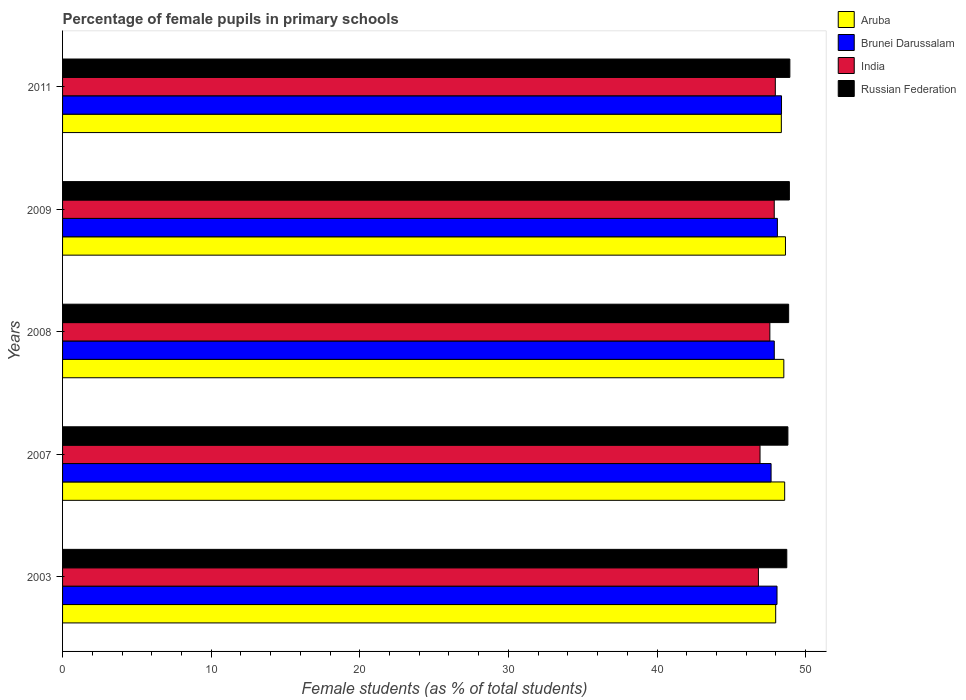Are the number of bars per tick equal to the number of legend labels?
Offer a terse response. Yes. Are the number of bars on each tick of the Y-axis equal?
Offer a terse response. Yes. How many bars are there on the 4th tick from the top?
Provide a short and direct response. 4. What is the label of the 4th group of bars from the top?
Ensure brevity in your answer.  2007. What is the percentage of female pupils in primary schools in India in 2009?
Offer a terse response. 47.89. Across all years, what is the maximum percentage of female pupils in primary schools in Russian Federation?
Offer a terse response. 48.94. Across all years, what is the minimum percentage of female pupils in primary schools in Aruba?
Your answer should be compact. 47.98. What is the total percentage of female pupils in primary schools in Aruba in the graph?
Provide a short and direct response. 242.11. What is the difference between the percentage of female pupils in primary schools in India in 2007 and that in 2009?
Give a very brief answer. -0.96. What is the difference between the percentage of female pupils in primary schools in India in 2007 and the percentage of female pupils in primary schools in Brunei Darussalam in 2003?
Your response must be concise. -1.14. What is the average percentage of female pupils in primary schools in Aruba per year?
Keep it short and to the point. 48.42. In the year 2009, what is the difference between the percentage of female pupils in primary schools in India and percentage of female pupils in primary schools in Brunei Darussalam?
Give a very brief answer. -0.21. What is the ratio of the percentage of female pupils in primary schools in Aruba in 2008 to that in 2011?
Your answer should be very brief. 1. Is the percentage of female pupils in primary schools in Russian Federation in 2007 less than that in 2011?
Give a very brief answer. Yes. Is the difference between the percentage of female pupils in primary schools in India in 2009 and 2011 greater than the difference between the percentage of female pupils in primary schools in Brunei Darussalam in 2009 and 2011?
Provide a succinct answer. Yes. What is the difference between the highest and the second highest percentage of female pupils in primary schools in Brunei Darussalam?
Ensure brevity in your answer.  0.28. What is the difference between the highest and the lowest percentage of female pupils in primary schools in Russian Federation?
Make the answer very short. 0.21. In how many years, is the percentage of female pupils in primary schools in Brunei Darussalam greater than the average percentage of female pupils in primary schools in Brunei Darussalam taken over all years?
Provide a succinct answer. 3. Is the sum of the percentage of female pupils in primary schools in Aruba in 2003 and 2009 greater than the maximum percentage of female pupils in primary schools in Brunei Darussalam across all years?
Make the answer very short. Yes. What does the 1st bar from the top in 2007 represents?
Provide a succinct answer. Russian Federation. What does the 1st bar from the bottom in 2007 represents?
Offer a very short reply. Aruba. Are all the bars in the graph horizontal?
Make the answer very short. Yes. Does the graph contain grids?
Make the answer very short. No. What is the title of the graph?
Your response must be concise. Percentage of female pupils in primary schools. What is the label or title of the X-axis?
Offer a terse response. Female students (as % of total students). What is the label or title of the Y-axis?
Keep it short and to the point. Years. What is the Female students (as % of total students) of Aruba in 2003?
Ensure brevity in your answer.  47.98. What is the Female students (as % of total students) in Brunei Darussalam in 2003?
Ensure brevity in your answer.  48.07. What is the Female students (as % of total students) of India in 2003?
Provide a short and direct response. 46.82. What is the Female students (as % of total students) of Russian Federation in 2003?
Your answer should be very brief. 48.73. What is the Female students (as % of total students) of Aruba in 2007?
Provide a short and direct response. 48.59. What is the Female students (as % of total students) in Brunei Darussalam in 2007?
Your response must be concise. 47.67. What is the Female students (as % of total students) in India in 2007?
Provide a succinct answer. 46.93. What is the Female students (as % of total students) of Russian Federation in 2007?
Ensure brevity in your answer.  48.81. What is the Female students (as % of total students) of Aruba in 2008?
Your answer should be very brief. 48.53. What is the Female students (as % of total students) of Brunei Darussalam in 2008?
Give a very brief answer. 47.89. What is the Female students (as % of total students) in India in 2008?
Give a very brief answer. 47.59. What is the Female students (as % of total students) in Russian Federation in 2008?
Your answer should be compact. 48.86. What is the Female students (as % of total students) of Aruba in 2009?
Give a very brief answer. 48.64. What is the Female students (as % of total students) in Brunei Darussalam in 2009?
Your answer should be compact. 48.1. What is the Female students (as % of total students) in India in 2009?
Offer a terse response. 47.89. What is the Female students (as % of total students) in Russian Federation in 2009?
Ensure brevity in your answer.  48.9. What is the Female students (as % of total students) of Aruba in 2011?
Offer a terse response. 48.36. What is the Female students (as % of total students) of Brunei Darussalam in 2011?
Your answer should be very brief. 48.38. What is the Female students (as % of total students) of India in 2011?
Provide a succinct answer. 47.96. What is the Female students (as % of total students) of Russian Federation in 2011?
Your answer should be very brief. 48.94. Across all years, what is the maximum Female students (as % of total students) of Aruba?
Make the answer very short. 48.64. Across all years, what is the maximum Female students (as % of total students) of Brunei Darussalam?
Make the answer very short. 48.38. Across all years, what is the maximum Female students (as % of total students) of India?
Keep it short and to the point. 47.96. Across all years, what is the maximum Female students (as % of total students) of Russian Federation?
Offer a very short reply. 48.94. Across all years, what is the minimum Female students (as % of total students) of Aruba?
Ensure brevity in your answer.  47.98. Across all years, what is the minimum Female students (as % of total students) in Brunei Darussalam?
Give a very brief answer. 47.67. Across all years, what is the minimum Female students (as % of total students) of India?
Make the answer very short. 46.82. Across all years, what is the minimum Female students (as % of total students) of Russian Federation?
Your answer should be compact. 48.73. What is the total Female students (as % of total students) in Aruba in the graph?
Give a very brief answer. 242.11. What is the total Female students (as % of total students) of Brunei Darussalam in the graph?
Your response must be concise. 240.11. What is the total Female students (as % of total students) in India in the graph?
Provide a succinct answer. 237.19. What is the total Female students (as % of total students) of Russian Federation in the graph?
Give a very brief answer. 244.24. What is the difference between the Female students (as % of total students) of Aruba in 2003 and that in 2007?
Provide a succinct answer. -0.6. What is the difference between the Female students (as % of total students) of Brunei Darussalam in 2003 and that in 2007?
Give a very brief answer. 0.4. What is the difference between the Female students (as % of total students) of India in 2003 and that in 2007?
Your answer should be very brief. -0.11. What is the difference between the Female students (as % of total students) in Russian Federation in 2003 and that in 2007?
Your answer should be compact. -0.07. What is the difference between the Female students (as % of total students) of Aruba in 2003 and that in 2008?
Provide a short and direct response. -0.55. What is the difference between the Female students (as % of total students) in Brunei Darussalam in 2003 and that in 2008?
Offer a terse response. 0.18. What is the difference between the Female students (as % of total students) of India in 2003 and that in 2008?
Offer a very short reply. -0.77. What is the difference between the Female students (as % of total students) of Russian Federation in 2003 and that in 2008?
Ensure brevity in your answer.  -0.12. What is the difference between the Female students (as % of total students) in Aruba in 2003 and that in 2009?
Provide a short and direct response. -0.66. What is the difference between the Female students (as % of total students) in Brunei Darussalam in 2003 and that in 2009?
Offer a very short reply. -0.03. What is the difference between the Female students (as % of total students) of India in 2003 and that in 2009?
Give a very brief answer. -1.06. What is the difference between the Female students (as % of total students) of Russian Federation in 2003 and that in 2009?
Give a very brief answer. -0.17. What is the difference between the Female students (as % of total students) in Aruba in 2003 and that in 2011?
Make the answer very short. -0.38. What is the difference between the Female students (as % of total students) in Brunei Darussalam in 2003 and that in 2011?
Keep it short and to the point. -0.3. What is the difference between the Female students (as % of total students) of India in 2003 and that in 2011?
Give a very brief answer. -1.14. What is the difference between the Female students (as % of total students) of Russian Federation in 2003 and that in 2011?
Your answer should be compact. -0.21. What is the difference between the Female students (as % of total students) of Aruba in 2007 and that in 2008?
Keep it short and to the point. 0.06. What is the difference between the Female students (as % of total students) of Brunei Darussalam in 2007 and that in 2008?
Offer a terse response. -0.21. What is the difference between the Female students (as % of total students) in India in 2007 and that in 2008?
Make the answer very short. -0.66. What is the difference between the Female students (as % of total students) in Russian Federation in 2007 and that in 2008?
Keep it short and to the point. -0.05. What is the difference between the Female students (as % of total students) in Aruba in 2007 and that in 2009?
Your response must be concise. -0.05. What is the difference between the Female students (as % of total students) in Brunei Darussalam in 2007 and that in 2009?
Your response must be concise. -0.42. What is the difference between the Female students (as % of total students) in India in 2007 and that in 2009?
Your answer should be very brief. -0.96. What is the difference between the Female students (as % of total students) of Russian Federation in 2007 and that in 2009?
Your response must be concise. -0.1. What is the difference between the Female students (as % of total students) in Aruba in 2007 and that in 2011?
Give a very brief answer. 0.22. What is the difference between the Female students (as % of total students) of Brunei Darussalam in 2007 and that in 2011?
Keep it short and to the point. -0.7. What is the difference between the Female students (as % of total students) of India in 2007 and that in 2011?
Offer a terse response. -1.03. What is the difference between the Female students (as % of total students) of Russian Federation in 2007 and that in 2011?
Your answer should be very brief. -0.13. What is the difference between the Female students (as % of total students) of Aruba in 2008 and that in 2009?
Make the answer very short. -0.11. What is the difference between the Female students (as % of total students) of Brunei Darussalam in 2008 and that in 2009?
Provide a short and direct response. -0.21. What is the difference between the Female students (as % of total students) of India in 2008 and that in 2009?
Make the answer very short. -0.29. What is the difference between the Female students (as % of total students) in Russian Federation in 2008 and that in 2009?
Make the answer very short. -0.05. What is the difference between the Female students (as % of total students) of Aruba in 2008 and that in 2011?
Provide a succinct answer. 0.17. What is the difference between the Female students (as % of total students) in Brunei Darussalam in 2008 and that in 2011?
Your answer should be compact. -0.49. What is the difference between the Female students (as % of total students) of India in 2008 and that in 2011?
Your answer should be very brief. -0.37. What is the difference between the Female students (as % of total students) of Russian Federation in 2008 and that in 2011?
Provide a succinct answer. -0.08. What is the difference between the Female students (as % of total students) of Aruba in 2009 and that in 2011?
Offer a terse response. 0.28. What is the difference between the Female students (as % of total students) of Brunei Darussalam in 2009 and that in 2011?
Your answer should be compact. -0.28. What is the difference between the Female students (as % of total students) in India in 2009 and that in 2011?
Ensure brevity in your answer.  -0.07. What is the difference between the Female students (as % of total students) in Russian Federation in 2009 and that in 2011?
Provide a short and direct response. -0.03. What is the difference between the Female students (as % of total students) in Aruba in 2003 and the Female students (as % of total students) in Brunei Darussalam in 2007?
Your answer should be compact. 0.31. What is the difference between the Female students (as % of total students) in Aruba in 2003 and the Female students (as % of total students) in India in 2007?
Offer a terse response. 1.05. What is the difference between the Female students (as % of total students) of Aruba in 2003 and the Female students (as % of total students) of Russian Federation in 2007?
Offer a terse response. -0.82. What is the difference between the Female students (as % of total students) of Brunei Darussalam in 2003 and the Female students (as % of total students) of India in 2007?
Provide a succinct answer. 1.14. What is the difference between the Female students (as % of total students) of Brunei Darussalam in 2003 and the Female students (as % of total students) of Russian Federation in 2007?
Offer a terse response. -0.73. What is the difference between the Female students (as % of total students) in India in 2003 and the Female students (as % of total students) in Russian Federation in 2007?
Ensure brevity in your answer.  -1.98. What is the difference between the Female students (as % of total students) in Aruba in 2003 and the Female students (as % of total students) in Brunei Darussalam in 2008?
Keep it short and to the point. 0.1. What is the difference between the Female students (as % of total students) of Aruba in 2003 and the Female students (as % of total students) of India in 2008?
Offer a terse response. 0.39. What is the difference between the Female students (as % of total students) of Aruba in 2003 and the Female students (as % of total students) of Russian Federation in 2008?
Provide a short and direct response. -0.87. What is the difference between the Female students (as % of total students) of Brunei Darussalam in 2003 and the Female students (as % of total students) of India in 2008?
Make the answer very short. 0.48. What is the difference between the Female students (as % of total students) in Brunei Darussalam in 2003 and the Female students (as % of total students) in Russian Federation in 2008?
Keep it short and to the point. -0.78. What is the difference between the Female students (as % of total students) in India in 2003 and the Female students (as % of total students) in Russian Federation in 2008?
Your answer should be compact. -2.03. What is the difference between the Female students (as % of total students) in Aruba in 2003 and the Female students (as % of total students) in Brunei Darussalam in 2009?
Provide a short and direct response. -0.11. What is the difference between the Female students (as % of total students) in Aruba in 2003 and the Female students (as % of total students) in India in 2009?
Your response must be concise. 0.1. What is the difference between the Female students (as % of total students) in Aruba in 2003 and the Female students (as % of total students) in Russian Federation in 2009?
Your response must be concise. -0.92. What is the difference between the Female students (as % of total students) of Brunei Darussalam in 2003 and the Female students (as % of total students) of India in 2009?
Give a very brief answer. 0.19. What is the difference between the Female students (as % of total students) of Brunei Darussalam in 2003 and the Female students (as % of total students) of Russian Federation in 2009?
Provide a short and direct response. -0.83. What is the difference between the Female students (as % of total students) of India in 2003 and the Female students (as % of total students) of Russian Federation in 2009?
Keep it short and to the point. -2.08. What is the difference between the Female students (as % of total students) of Aruba in 2003 and the Female students (as % of total students) of Brunei Darussalam in 2011?
Your answer should be compact. -0.39. What is the difference between the Female students (as % of total students) of Aruba in 2003 and the Female students (as % of total students) of India in 2011?
Provide a short and direct response. 0.02. What is the difference between the Female students (as % of total students) of Aruba in 2003 and the Female students (as % of total students) of Russian Federation in 2011?
Provide a short and direct response. -0.95. What is the difference between the Female students (as % of total students) in Brunei Darussalam in 2003 and the Female students (as % of total students) in India in 2011?
Make the answer very short. 0.11. What is the difference between the Female students (as % of total students) of Brunei Darussalam in 2003 and the Female students (as % of total students) of Russian Federation in 2011?
Your response must be concise. -0.86. What is the difference between the Female students (as % of total students) of India in 2003 and the Female students (as % of total students) of Russian Federation in 2011?
Your answer should be very brief. -2.12. What is the difference between the Female students (as % of total students) in Aruba in 2007 and the Female students (as % of total students) in Brunei Darussalam in 2008?
Your answer should be compact. 0.7. What is the difference between the Female students (as % of total students) in Aruba in 2007 and the Female students (as % of total students) in India in 2008?
Provide a succinct answer. 1. What is the difference between the Female students (as % of total students) in Aruba in 2007 and the Female students (as % of total students) in Russian Federation in 2008?
Give a very brief answer. -0.27. What is the difference between the Female students (as % of total students) in Brunei Darussalam in 2007 and the Female students (as % of total students) in India in 2008?
Keep it short and to the point. 0.08. What is the difference between the Female students (as % of total students) of Brunei Darussalam in 2007 and the Female students (as % of total students) of Russian Federation in 2008?
Offer a very short reply. -1.18. What is the difference between the Female students (as % of total students) in India in 2007 and the Female students (as % of total students) in Russian Federation in 2008?
Give a very brief answer. -1.93. What is the difference between the Female students (as % of total students) in Aruba in 2007 and the Female students (as % of total students) in Brunei Darussalam in 2009?
Ensure brevity in your answer.  0.49. What is the difference between the Female students (as % of total students) of Aruba in 2007 and the Female students (as % of total students) of India in 2009?
Give a very brief answer. 0.7. What is the difference between the Female students (as % of total students) in Aruba in 2007 and the Female students (as % of total students) in Russian Federation in 2009?
Offer a very short reply. -0.32. What is the difference between the Female students (as % of total students) in Brunei Darussalam in 2007 and the Female students (as % of total students) in India in 2009?
Offer a terse response. -0.21. What is the difference between the Female students (as % of total students) in Brunei Darussalam in 2007 and the Female students (as % of total students) in Russian Federation in 2009?
Offer a terse response. -1.23. What is the difference between the Female students (as % of total students) of India in 2007 and the Female students (as % of total students) of Russian Federation in 2009?
Your answer should be very brief. -1.97. What is the difference between the Female students (as % of total students) of Aruba in 2007 and the Female students (as % of total students) of Brunei Darussalam in 2011?
Your answer should be very brief. 0.21. What is the difference between the Female students (as % of total students) of Aruba in 2007 and the Female students (as % of total students) of India in 2011?
Provide a succinct answer. 0.63. What is the difference between the Female students (as % of total students) in Aruba in 2007 and the Female students (as % of total students) in Russian Federation in 2011?
Your response must be concise. -0.35. What is the difference between the Female students (as % of total students) of Brunei Darussalam in 2007 and the Female students (as % of total students) of India in 2011?
Ensure brevity in your answer.  -0.29. What is the difference between the Female students (as % of total students) in Brunei Darussalam in 2007 and the Female students (as % of total students) in Russian Federation in 2011?
Your response must be concise. -1.26. What is the difference between the Female students (as % of total students) in India in 2007 and the Female students (as % of total students) in Russian Federation in 2011?
Your answer should be compact. -2.01. What is the difference between the Female students (as % of total students) of Aruba in 2008 and the Female students (as % of total students) of Brunei Darussalam in 2009?
Your answer should be very brief. 0.43. What is the difference between the Female students (as % of total students) in Aruba in 2008 and the Female students (as % of total students) in India in 2009?
Provide a short and direct response. 0.64. What is the difference between the Female students (as % of total students) of Aruba in 2008 and the Female students (as % of total students) of Russian Federation in 2009?
Provide a short and direct response. -0.37. What is the difference between the Female students (as % of total students) of Brunei Darussalam in 2008 and the Female students (as % of total students) of India in 2009?
Provide a succinct answer. 0. What is the difference between the Female students (as % of total students) in Brunei Darussalam in 2008 and the Female students (as % of total students) in Russian Federation in 2009?
Your answer should be compact. -1.02. What is the difference between the Female students (as % of total students) in India in 2008 and the Female students (as % of total students) in Russian Federation in 2009?
Keep it short and to the point. -1.31. What is the difference between the Female students (as % of total students) of Aruba in 2008 and the Female students (as % of total students) of Brunei Darussalam in 2011?
Keep it short and to the point. 0.16. What is the difference between the Female students (as % of total students) in Aruba in 2008 and the Female students (as % of total students) in India in 2011?
Ensure brevity in your answer.  0.57. What is the difference between the Female students (as % of total students) of Aruba in 2008 and the Female students (as % of total students) of Russian Federation in 2011?
Your answer should be very brief. -0.41. What is the difference between the Female students (as % of total students) in Brunei Darussalam in 2008 and the Female students (as % of total students) in India in 2011?
Your response must be concise. -0.07. What is the difference between the Female students (as % of total students) in Brunei Darussalam in 2008 and the Female students (as % of total students) in Russian Federation in 2011?
Ensure brevity in your answer.  -1.05. What is the difference between the Female students (as % of total students) in India in 2008 and the Female students (as % of total students) in Russian Federation in 2011?
Your response must be concise. -1.35. What is the difference between the Female students (as % of total students) of Aruba in 2009 and the Female students (as % of total students) of Brunei Darussalam in 2011?
Your answer should be compact. 0.27. What is the difference between the Female students (as % of total students) of Aruba in 2009 and the Female students (as % of total students) of India in 2011?
Ensure brevity in your answer.  0.68. What is the difference between the Female students (as % of total students) of Aruba in 2009 and the Female students (as % of total students) of Russian Federation in 2011?
Provide a succinct answer. -0.3. What is the difference between the Female students (as % of total students) in Brunei Darussalam in 2009 and the Female students (as % of total students) in India in 2011?
Provide a succinct answer. 0.14. What is the difference between the Female students (as % of total students) in Brunei Darussalam in 2009 and the Female students (as % of total students) in Russian Federation in 2011?
Provide a short and direct response. -0.84. What is the difference between the Female students (as % of total students) in India in 2009 and the Female students (as % of total students) in Russian Federation in 2011?
Provide a succinct answer. -1.05. What is the average Female students (as % of total students) of Aruba per year?
Offer a very short reply. 48.42. What is the average Female students (as % of total students) of Brunei Darussalam per year?
Your answer should be very brief. 48.02. What is the average Female students (as % of total students) of India per year?
Make the answer very short. 47.44. What is the average Female students (as % of total students) of Russian Federation per year?
Your response must be concise. 48.85. In the year 2003, what is the difference between the Female students (as % of total students) in Aruba and Female students (as % of total students) in Brunei Darussalam?
Offer a terse response. -0.09. In the year 2003, what is the difference between the Female students (as % of total students) of Aruba and Female students (as % of total students) of India?
Offer a very short reply. 1.16. In the year 2003, what is the difference between the Female students (as % of total students) of Aruba and Female students (as % of total students) of Russian Federation?
Your answer should be compact. -0.75. In the year 2003, what is the difference between the Female students (as % of total students) of Brunei Darussalam and Female students (as % of total students) of India?
Offer a terse response. 1.25. In the year 2003, what is the difference between the Female students (as % of total students) of Brunei Darussalam and Female students (as % of total students) of Russian Federation?
Offer a very short reply. -0.66. In the year 2003, what is the difference between the Female students (as % of total students) in India and Female students (as % of total students) in Russian Federation?
Your answer should be compact. -1.91. In the year 2007, what is the difference between the Female students (as % of total students) in Aruba and Female students (as % of total students) in Brunei Darussalam?
Keep it short and to the point. 0.91. In the year 2007, what is the difference between the Female students (as % of total students) of Aruba and Female students (as % of total students) of India?
Offer a terse response. 1.66. In the year 2007, what is the difference between the Female students (as % of total students) of Aruba and Female students (as % of total students) of Russian Federation?
Offer a very short reply. -0.22. In the year 2007, what is the difference between the Female students (as % of total students) of Brunei Darussalam and Female students (as % of total students) of India?
Keep it short and to the point. 0.74. In the year 2007, what is the difference between the Female students (as % of total students) of Brunei Darussalam and Female students (as % of total students) of Russian Federation?
Offer a terse response. -1.13. In the year 2007, what is the difference between the Female students (as % of total students) in India and Female students (as % of total students) in Russian Federation?
Give a very brief answer. -1.88. In the year 2008, what is the difference between the Female students (as % of total students) in Aruba and Female students (as % of total students) in Brunei Darussalam?
Keep it short and to the point. 0.64. In the year 2008, what is the difference between the Female students (as % of total students) of Aruba and Female students (as % of total students) of India?
Your response must be concise. 0.94. In the year 2008, what is the difference between the Female students (as % of total students) in Aruba and Female students (as % of total students) in Russian Federation?
Make the answer very short. -0.32. In the year 2008, what is the difference between the Female students (as % of total students) of Brunei Darussalam and Female students (as % of total students) of India?
Make the answer very short. 0.3. In the year 2008, what is the difference between the Female students (as % of total students) of Brunei Darussalam and Female students (as % of total students) of Russian Federation?
Keep it short and to the point. -0.97. In the year 2008, what is the difference between the Female students (as % of total students) in India and Female students (as % of total students) in Russian Federation?
Ensure brevity in your answer.  -1.26. In the year 2009, what is the difference between the Female students (as % of total students) in Aruba and Female students (as % of total students) in Brunei Darussalam?
Your answer should be very brief. 0.54. In the year 2009, what is the difference between the Female students (as % of total students) of Aruba and Female students (as % of total students) of India?
Make the answer very short. 0.76. In the year 2009, what is the difference between the Female students (as % of total students) in Aruba and Female students (as % of total students) in Russian Federation?
Provide a succinct answer. -0.26. In the year 2009, what is the difference between the Female students (as % of total students) of Brunei Darussalam and Female students (as % of total students) of India?
Offer a terse response. 0.21. In the year 2009, what is the difference between the Female students (as % of total students) of Brunei Darussalam and Female students (as % of total students) of Russian Federation?
Keep it short and to the point. -0.81. In the year 2009, what is the difference between the Female students (as % of total students) of India and Female students (as % of total students) of Russian Federation?
Offer a terse response. -1.02. In the year 2011, what is the difference between the Female students (as % of total students) of Aruba and Female students (as % of total students) of Brunei Darussalam?
Make the answer very short. -0.01. In the year 2011, what is the difference between the Female students (as % of total students) in Aruba and Female students (as % of total students) in India?
Give a very brief answer. 0.4. In the year 2011, what is the difference between the Female students (as % of total students) of Aruba and Female students (as % of total students) of Russian Federation?
Give a very brief answer. -0.57. In the year 2011, what is the difference between the Female students (as % of total students) in Brunei Darussalam and Female students (as % of total students) in India?
Your response must be concise. 0.42. In the year 2011, what is the difference between the Female students (as % of total students) in Brunei Darussalam and Female students (as % of total students) in Russian Federation?
Provide a succinct answer. -0.56. In the year 2011, what is the difference between the Female students (as % of total students) of India and Female students (as % of total students) of Russian Federation?
Your response must be concise. -0.98. What is the ratio of the Female students (as % of total students) in Aruba in 2003 to that in 2007?
Offer a very short reply. 0.99. What is the ratio of the Female students (as % of total students) of Brunei Darussalam in 2003 to that in 2007?
Make the answer very short. 1.01. What is the ratio of the Female students (as % of total students) in Russian Federation in 2003 to that in 2007?
Your response must be concise. 1. What is the ratio of the Female students (as % of total students) in Aruba in 2003 to that in 2008?
Keep it short and to the point. 0.99. What is the ratio of the Female students (as % of total students) in India in 2003 to that in 2008?
Offer a terse response. 0.98. What is the ratio of the Female students (as % of total students) of Aruba in 2003 to that in 2009?
Provide a short and direct response. 0.99. What is the ratio of the Female students (as % of total students) in India in 2003 to that in 2009?
Provide a succinct answer. 0.98. What is the ratio of the Female students (as % of total students) in Aruba in 2003 to that in 2011?
Make the answer very short. 0.99. What is the ratio of the Female students (as % of total students) in Brunei Darussalam in 2003 to that in 2011?
Your answer should be compact. 0.99. What is the ratio of the Female students (as % of total students) in India in 2003 to that in 2011?
Offer a terse response. 0.98. What is the ratio of the Female students (as % of total students) of Russian Federation in 2003 to that in 2011?
Your answer should be compact. 1. What is the ratio of the Female students (as % of total students) of Aruba in 2007 to that in 2008?
Offer a terse response. 1. What is the ratio of the Female students (as % of total students) of Brunei Darussalam in 2007 to that in 2008?
Your response must be concise. 1. What is the ratio of the Female students (as % of total students) of India in 2007 to that in 2008?
Give a very brief answer. 0.99. What is the ratio of the Female students (as % of total students) in Aruba in 2007 to that in 2011?
Give a very brief answer. 1. What is the ratio of the Female students (as % of total students) in Brunei Darussalam in 2007 to that in 2011?
Your response must be concise. 0.99. What is the ratio of the Female students (as % of total students) of India in 2007 to that in 2011?
Ensure brevity in your answer.  0.98. What is the ratio of the Female students (as % of total students) in Aruba in 2008 to that in 2011?
Make the answer very short. 1. What is the ratio of the Female students (as % of total students) of India in 2008 to that in 2011?
Provide a short and direct response. 0.99. What is the ratio of the Female students (as % of total students) of Aruba in 2009 to that in 2011?
Ensure brevity in your answer.  1.01. What is the ratio of the Female students (as % of total students) of Russian Federation in 2009 to that in 2011?
Offer a very short reply. 1. What is the difference between the highest and the second highest Female students (as % of total students) of Aruba?
Provide a short and direct response. 0.05. What is the difference between the highest and the second highest Female students (as % of total students) in Brunei Darussalam?
Make the answer very short. 0.28. What is the difference between the highest and the second highest Female students (as % of total students) of India?
Your answer should be compact. 0.07. What is the difference between the highest and the second highest Female students (as % of total students) of Russian Federation?
Your answer should be compact. 0.03. What is the difference between the highest and the lowest Female students (as % of total students) in Aruba?
Give a very brief answer. 0.66. What is the difference between the highest and the lowest Female students (as % of total students) of Brunei Darussalam?
Your answer should be very brief. 0.7. What is the difference between the highest and the lowest Female students (as % of total students) of India?
Provide a short and direct response. 1.14. What is the difference between the highest and the lowest Female students (as % of total students) of Russian Federation?
Offer a terse response. 0.21. 